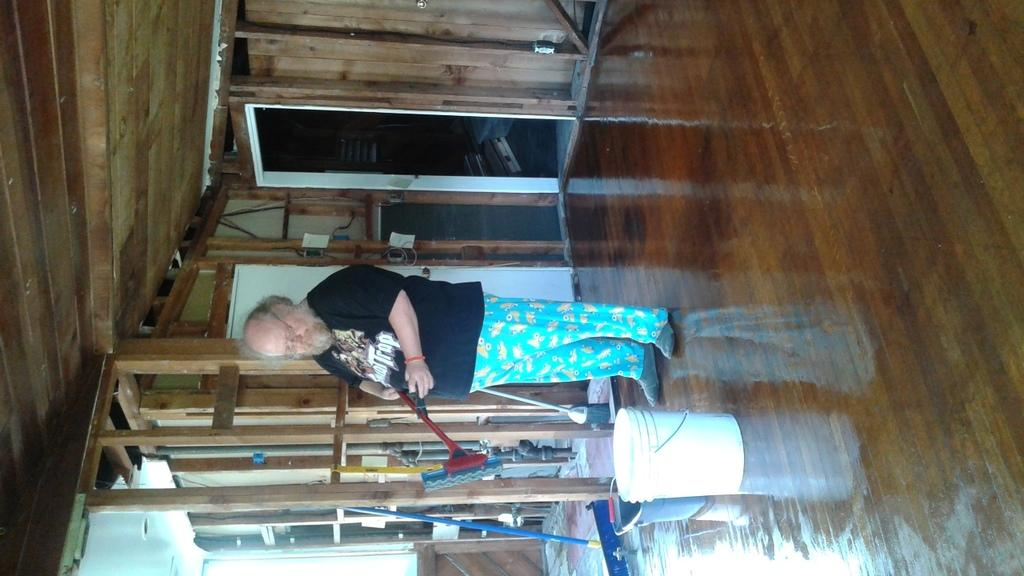What is the main subject of the image? There is a person in the image. What is the person doing in the image? The person is standing. What is the person wearing in the image? The person is wearing a black shirt and blue pants. What is the person holding in the image? The person is holding an object. What can be seen in the background of the image? There is a wooden door in the background of the image. How many pigs are visible in the image? There are no pigs present in the image. What type of wine is the person drinking in the image? There is no wine present in the image, and the person is not drinking anything. 